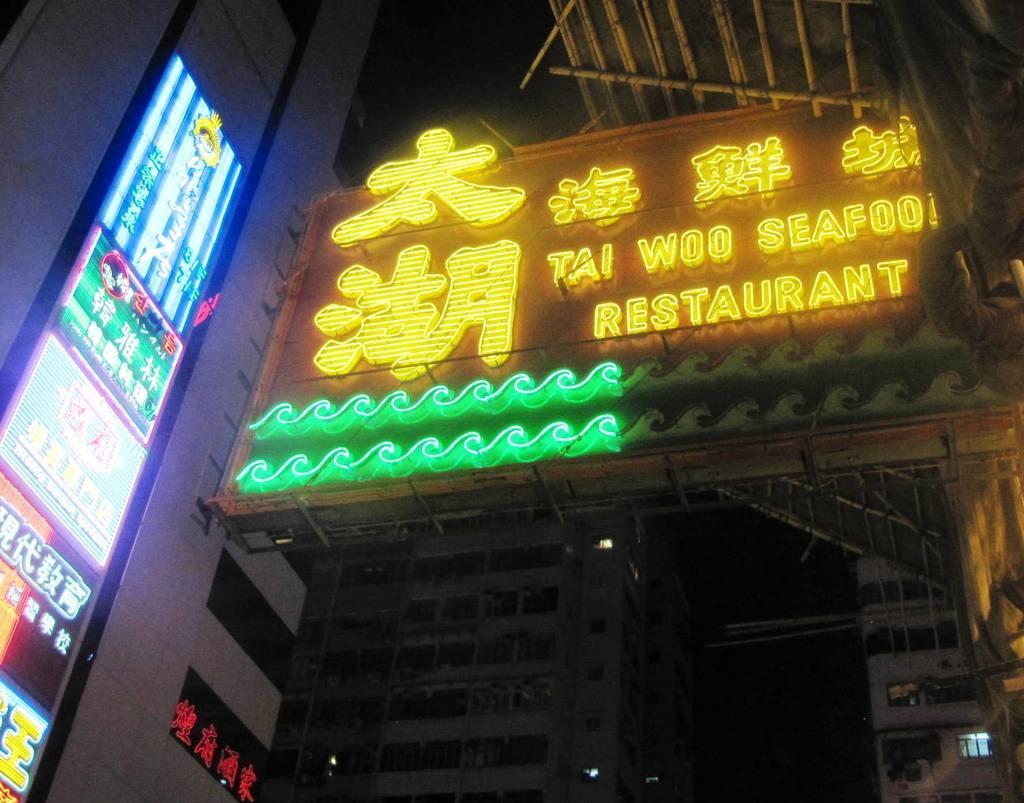How would you summarize this image in a sentence or two? In the picture we can see a restaurant board which is attached to the building with lights and behind it we can see some building with windows. 